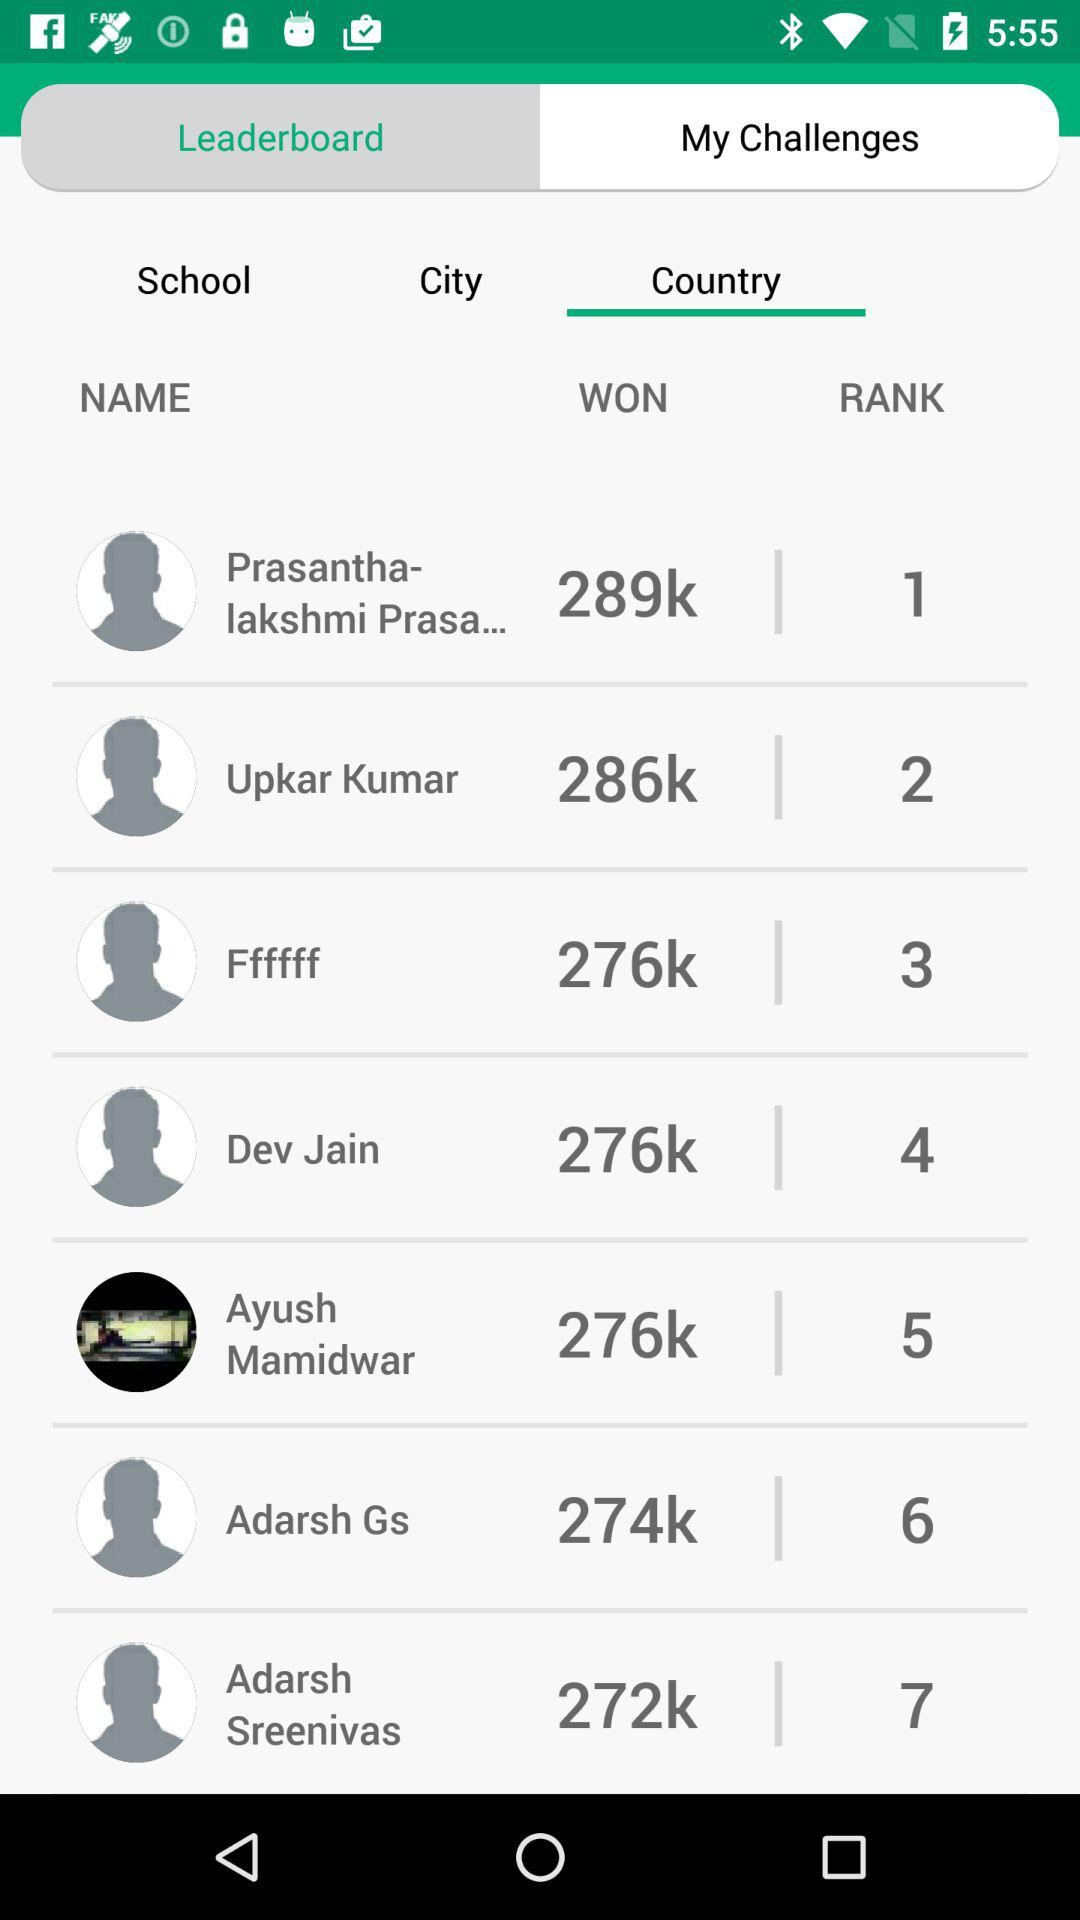Who was ranked seventh? The person who was ranked seventh is Adarsh Sreenivas. 